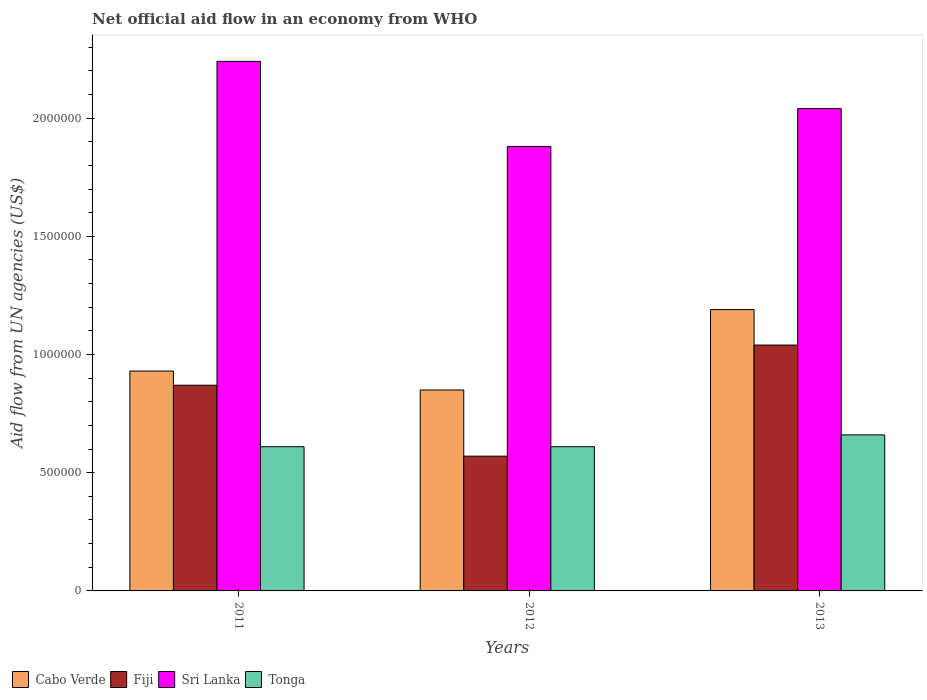How many different coloured bars are there?
Keep it short and to the point. 4. How many bars are there on the 3rd tick from the left?
Your answer should be compact. 4. How many bars are there on the 3rd tick from the right?
Your response must be concise. 4. What is the label of the 2nd group of bars from the left?
Give a very brief answer. 2012. In how many cases, is the number of bars for a given year not equal to the number of legend labels?
Provide a succinct answer. 0. Across all years, what is the maximum net official aid flow in Sri Lanka?
Your response must be concise. 2.24e+06. Across all years, what is the minimum net official aid flow in Cabo Verde?
Ensure brevity in your answer.  8.50e+05. In which year was the net official aid flow in Sri Lanka maximum?
Offer a very short reply. 2011. In which year was the net official aid flow in Fiji minimum?
Keep it short and to the point. 2012. What is the total net official aid flow in Tonga in the graph?
Offer a very short reply. 1.88e+06. What is the difference between the net official aid flow in Cabo Verde in 2011 and the net official aid flow in Tonga in 2013?
Make the answer very short. 2.70e+05. What is the average net official aid flow in Sri Lanka per year?
Keep it short and to the point. 2.05e+06. In the year 2013, what is the difference between the net official aid flow in Tonga and net official aid flow in Fiji?
Provide a succinct answer. -3.80e+05. In how many years, is the net official aid flow in Sri Lanka greater than 1500000 US$?
Provide a short and direct response. 3. What is the ratio of the net official aid flow in Fiji in 2012 to that in 2013?
Keep it short and to the point. 0.55. Is the net official aid flow in Fiji in 2012 less than that in 2013?
Offer a terse response. Yes. Is the difference between the net official aid flow in Tonga in 2011 and 2013 greater than the difference between the net official aid flow in Fiji in 2011 and 2013?
Offer a very short reply. Yes. In how many years, is the net official aid flow in Fiji greater than the average net official aid flow in Fiji taken over all years?
Provide a short and direct response. 2. What does the 4th bar from the left in 2011 represents?
Your answer should be compact. Tonga. What does the 3rd bar from the right in 2013 represents?
Offer a terse response. Fiji. Is it the case that in every year, the sum of the net official aid flow in Fiji and net official aid flow in Cabo Verde is greater than the net official aid flow in Tonga?
Offer a very short reply. Yes. How many years are there in the graph?
Provide a succinct answer. 3. What is the difference between two consecutive major ticks on the Y-axis?
Your response must be concise. 5.00e+05. Where does the legend appear in the graph?
Your answer should be very brief. Bottom left. How many legend labels are there?
Your answer should be compact. 4. How are the legend labels stacked?
Keep it short and to the point. Horizontal. What is the title of the graph?
Ensure brevity in your answer.  Net official aid flow in an economy from WHO. What is the label or title of the Y-axis?
Ensure brevity in your answer.  Aid flow from UN agencies (US$). What is the Aid flow from UN agencies (US$) of Cabo Verde in 2011?
Your answer should be very brief. 9.30e+05. What is the Aid flow from UN agencies (US$) of Fiji in 2011?
Ensure brevity in your answer.  8.70e+05. What is the Aid flow from UN agencies (US$) in Sri Lanka in 2011?
Provide a short and direct response. 2.24e+06. What is the Aid flow from UN agencies (US$) of Cabo Verde in 2012?
Offer a very short reply. 8.50e+05. What is the Aid flow from UN agencies (US$) of Fiji in 2012?
Offer a very short reply. 5.70e+05. What is the Aid flow from UN agencies (US$) of Sri Lanka in 2012?
Offer a terse response. 1.88e+06. What is the Aid flow from UN agencies (US$) of Tonga in 2012?
Provide a short and direct response. 6.10e+05. What is the Aid flow from UN agencies (US$) in Cabo Verde in 2013?
Your response must be concise. 1.19e+06. What is the Aid flow from UN agencies (US$) in Fiji in 2013?
Your answer should be compact. 1.04e+06. What is the Aid flow from UN agencies (US$) of Sri Lanka in 2013?
Your answer should be compact. 2.04e+06. What is the Aid flow from UN agencies (US$) of Tonga in 2013?
Keep it short and to the point. 6.60e+05. Across all years, what is the maximum Aid flow from UN agencies (US$) of Cabo Verde?
Provide a short and direct response. 1.19e+06. Across all years, what is the maximum Aid flow from UN agencies (US$) of Fiji?
Give a very brief answer. 1.04e+06. Across all years, what is the maximum Aid flow from UN agencies (US$) in Sri Lanka?
Your answer should be compact. 2.24e+06. Across all years, what is the minimum Aid flow from UN agencies (US$) in Cabo Verde?
Keep it short and to the point. 8.50e+05. Across all years, what is the minimum Aid flow from UN agencies (US$) in Fiji?
Provide a short and direct response. 5.70e+05. Across all years, what is the minimum Aid flow from UN agencies (US$) in Sri Lanka?
Your answer should be very brief. 1.88e+06. Across all years, what is the minimum Aid flow from UN agencies (US$) in Tonga?
Provide a short and direct response. 6.10e+05. What is the total Aid flow from UN agencies (US$) in Cabo Verde in the graph?
Your answer should be compact. 2.97e+06. What is the total Aid flow from UN agencies (US$) in Fiji in the graph?
Offer a very short reply. 2.48e+06. What is the total Aid flow from UN agencies (US$) in Sri Lanka in the graph?
Offer a very short reply. 6.16e+06. What is the total Aid flow from UN agencies (US$) of Tonga in the graph?
Keep it short and to the point. 1.88e+06. What is the difference between the Aid flow from UN agencies (US$) in Fiji in 2011 and that in 2012?
Your answer should be very brief. 3.00e+05. What is the difference between the Aid flow from UN agencies (US$) of Sri Lanka in 2011 and that in 2012?
Keep it short and to the point. 3.60e+05. What is the difference between the Aid flow from UN agencies (US$) of Tonga in 2011 and that in 2012?
Your answer should be very brief. 0. What is the difference between the Aid flow from UN agencies (US$) of Fiji in 2011 and that in 2013?
Your response must be concise. -1.70e+05. What is the difference between the Aid flow from UN agencies (US$) in Fiji in 2012 and that in 2013?
Offer a very short reply. -4.70e+05. What is the difference between the Aid flow from UN agencies (US$) in Sri Lanka in 2012 and that in 2013?
Your answer should be very brief. -1.60e+05. What is the difference between the Aid flow from UN agencies (US$) of Cabo Verde in 2011 and the Aid flow from UN agencies (US$) of Sri Lanka in 2012?
Provide a succinct answer. -9.50e+05. What is the difference between the Aid flow from UN agencies (US$) of Cabo Verde in 2011 and the Aid flow from UN agencies (US$) of Tonga in 2012?
Ensure brevity in your answer.  3.20e+05. What is the difference between the Aid flow from UN agencies (US$) in Fiji in 2011 and the Aid flow from UN agencies (US$) in Sri Lanka in 2012?
Ensure brevity in your answer.  -1.01e+06. What is the difference between the Aid flow from UN agencies (US$) of Sri Lanka in 2011 and the Aid flow from UN agencies (US$) of Tonga in 2012?
Give a very brief answer. 1.63e+06. What is the difference between the Aid flow from UN agencies (US$) in Cabo Verde in 2011 and the Aid flow from UN agencies (US$) in Sri Lanka in 2013?
Your response must be concise. -1.11e+06. What is the difference between the Aid flow from UN agencies (US$) in Cabo Verde in 2011 and the Aid flow from UN agencies (US$) in Tonga in 2013?
Provide a succinct answer. 2.70e+05. What is the difference between the Aid flow from UN agencies (US$) of Fiji in 2011 and the Aid flow from UN agencies (US$) of Sri Lanka in 2013?
Your answer should be very brief. -1.17e+06. What is the difference between the Aid flow from UN agencies (US$) of Sri Lanka in 2011 and the Aid flow from UN agencies (US$) of Tonga in 2013?
Give a very brief answer. 1.58e+06. What is the difference between the Aid flow from UN agencies (US$) of Cabo Verde in 2012 and the Aid flow from UN agencies (US$) of Fiji in 2013?
Make the answer very short. -1.90e+05. What is the difference between the Aid flow from UN agencies (US$) in Cabo Verde in 2012 and the Aid flow from UN agencies (US$) in Sri Lanka in 2013?
Your answer should be compact. -1.19e+06. What is the difference between the Aid flow from UN agencies (US$) in Cabo Verde in 2012 and the Aid flow from UN agencies (US$) in Tonga in 2013?
Offer a terse response. 1.90e+05. What is the difference between the Aid flow from UN agencies (US$) of Fiji in 2012 and the Aid flow from UN agencies (US$) of Sri Lanka in 2013?
Offer a terse response. -1.47e+06. What is the difference between the Aid flow from UN agencies (US$) of Sri Lanka in 2012 and the Aid flow from UN agencies (US$) of Tonga in 2013?
Give a very brief answer. 1.22e+06. What is the average Aid flow from UN agencies (US$) of Cabo Verde per year?
Ensure brevity in your answer.  9.90e+05. What is the average Aid flow from UN agencies (US$) in Fiji per year?
Ensure brevity in your answer.  8.27e+05. What is the average Aid flow from UN agencies (US$) of Sri Lanka per year?
Your answer should be compact. 2.05e+06. What is the average Aid flow from UN agencies (US$) in Tonga per year?
Give a very brief answer. 6.27e+05. In the year 2011, what is the difference between the Aid flow from UN agencies (US$) of Cabo Verde and Aid flow from UN agencies (US$) of Fiji?
Your answer should be compact. 6.00e+04. In the year 2011, what is the difference between the Aid flow from UN agencies (US$) of Cabo Verde and Aid flow from UN agencies (US$) of Sri Lanka?
Your response must be concise. -1.31e+06. In the year 2011, what is the difference between the Aid flow from UN agencies (US$) of Cabo Verde and Aid flow from UN agencies (US$) of Tonga?
Give a very brief answer. 3.20e+05. In the year 2011, what is the difference between the Aid flow from UN agencies (US$) in Fiji and Aid flow from UN agencies (US$) in Sri Lanka?
Provide a succinct answer. -1.37e+06. In the year 2011, what is the difference between the Aid flow from UN agencies (US$) of Sri Lanka and Aid flow from UN agencies (US$) of Tonga?
Ensure brevity in your answer.  1.63e+06. In the year 2012, what is the difference between the Aid flow from UN agencies (US$) in Cabo Verde and Aid flow from UN agencies (US$) in Fiji?
Make the answer very short. 2.80e+05. In the year 2012, what is the difference between the Aid flow from UN agencies (US$) of Cabo Verde and Aid flow from UN agencies (US$) of Sri Lanka?
Ensure brevity in your answer.  -1.03e+06. In the year 2012, what is the difference between the Aid flow from UN agencies (US$) of Fiji and Aid flow from UN agencies (US$) of Sri Lanka?
Provide a short and direct response. -1.31e+06. In the year 2012, what is the difference between the Aid flow from UN agencies (US$) in Sri Lanka and Aid flow from UN agencies (US$) in Tonga?
Give a very brief answer. 1.27e+06. In the year 2013, what is the difference between the Aid flow from UN agencies (US$) of Cabo Verde and Aid flow from UN agencies (US$) of Fiji?
Offer a very short reply. 1.50e+05. In the year 2013, what is the difference between the Aid flow from UN agencies (US$) of Cabo Verde and Aid flow from UN agencies (US$) of Sri Lanka?
Offer a very short reply. -8.50e+05. In the year 2013, what is the difference between the Aid flow from UN agencies (US$) of Cabo Verde and Aid flow from UN agencies (US$) of Tonga?
Your response must be concise. 5.30e+05. In the year 2013, what is the difference between the Aid flow from UN agencies (US$) in Fiji and Aid flow from UN agencies (US$) in Sri Lanka?
Ensure brevity in your answer.  -1.00e+06. In the year 2013, what is the difference between the Aid flow from UN agencies (US$) of Fiji and Aid flow from UN agencies (US$) of Tonga?
Your answer should be very brief. 3.80e+05. In the year 2013, what is the difference between the Aid flow from UN agencies (US$) of Sri Lanka and Aid flow from UN agencies (US$) of Tonga?
Your response must be concise. 1.38e+06. What is the ratio of the Aid flow from UN agencies (US$) of Cabo Verde in 2011 to that in 2012?
Make the answer very short. 1.09. What is the ratio of the Aid flow from UN agencies (US$) of Fiji in 2011 to that in 2012?
Make the answer very short. 1.53. What is the ratio of the Aid flow from UN agencies (US$) of Sri Lanka in 2011 to that in 2012?
Offer a very short reply. 1.19. What is the ratio of the Aid flow from UN agencies (US$) in Cabo Verde in 2011 to that in 2013?
Your answer should be very brief. 0.78. What is the ratio of the Aid flow from UN agencies (US$) of Fiji in 2011 to that in 2013?
Make the answer very short. 0.84. What is the ratio of the Aid flow from UN agencies (US$) of Sri Lanka in 2011 to that in 2013?
Give a very brief answer. 1.1. What is the ratio of the Aid flow from UN agencies (US$) of Tonga in 2011 to that in 2013?
Ensure brevity in your answer.  0.92. What is the ratio of the Aid flow from UN agencies (US$) of Cabo Verde in 2012 to that in 2013?
Your answer should be compact. 0.71. What is the ratio of the Aid flow from UN agencies (US$) of Fiji in 2012 to that in 2013?
Ensure brevity in your answer.  0.55. What is the ratio of the Aid flow from UN agencies (US$) of Sri Lanka in 2012 to that in 2013?
Make the answer very short. 0.92. What is the ratio of the Aid flow from UN agencies (US$) of Tonga in 2012 to that in 2013?
Give a very brief answer. 0.92. What is the difference between the highest and the second highest Aid flow from UN agencies (US$) of Cabo Verde?
Provide a succinct answer. 2.60e+05. What is the difference between the highest and the lowest Aid flow from UN agencies (US$) of Fiji?
Ensure brevity in your answer.  4.70e+05. What is the difference between the highest and the lowest Aid flow from UN agencies (US$) of Sri Lanka?
Make the answer very short. 3.60e+05. What is the difference between the highest and the lowest Aid flow from UN agencies (US$) of Tonga?
Make the answer very short. 5.00e+04. 